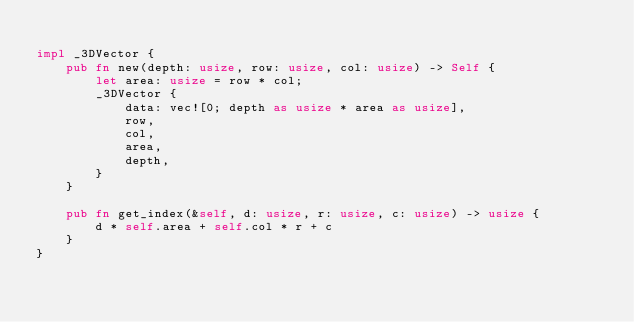<code> <loc_0><loc_0><loc_500><loc_500><_Rust_>
impl _3DVector {
    pub fn new(depth: usize, row: usize, col: usize) -> Self {
        let area: usize = row * col;
        _3DVector {
            data: vec![0; depth as usize * area as usize],
            row,
            col,
            area,
            depth,
        }
    }

    pub fn get_index(&self, d: usize, r: usize, c: usize) -> usize {
        d * self.area + self.col * r + c
    }
}
</code> 